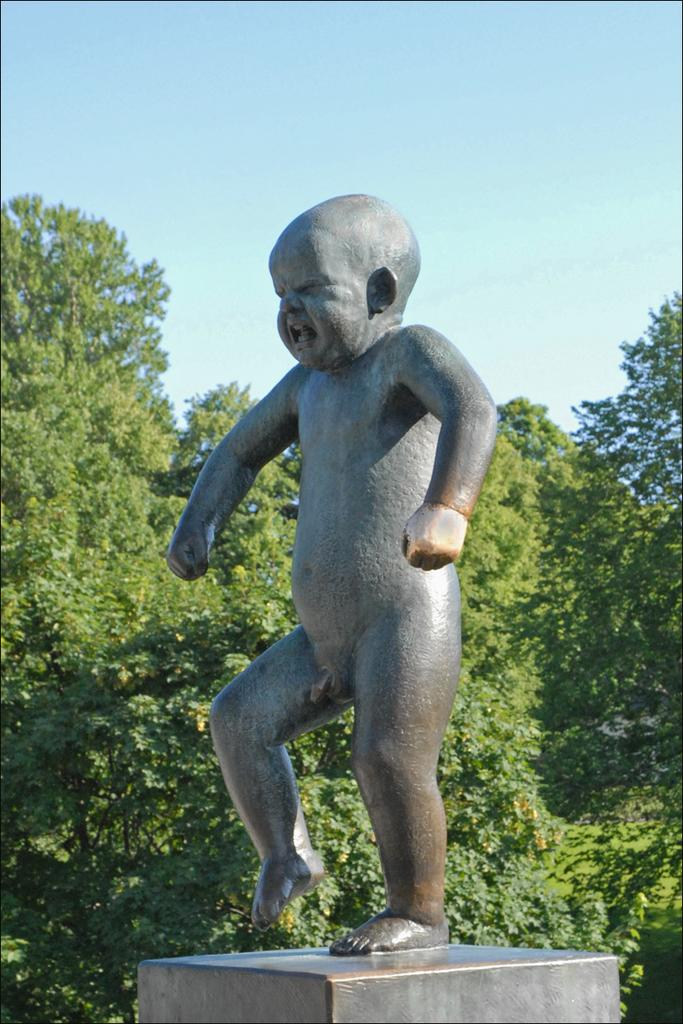What is the main subject of the image? There is a statue of a boy in the image. What type of natural elements can be seen in the image? There are trees in the image. What can be seen in the background of the image? The sky is visible in the background of the image. What type of business is being conducted in the image? There is no indication of any business being conducted in the image; it primarily features a statue of a boy and trees. 